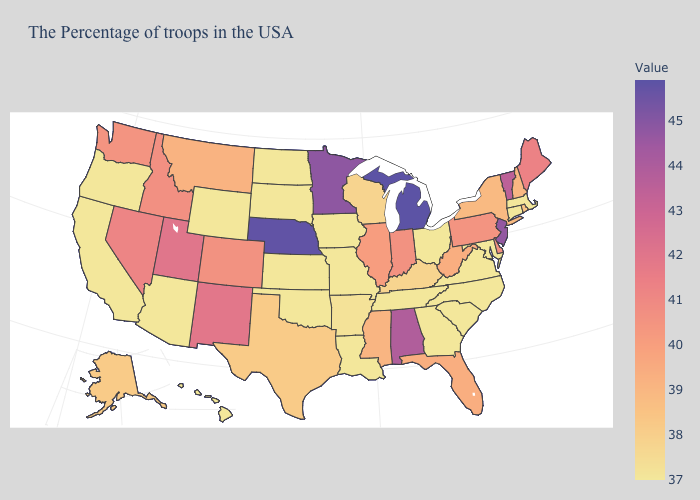Among the states that border New Hampshire , which have the lowest value?
Quick response, please. Massachusetts. Does Rhode Island have the highest value in the USA?
Be succinct. No. Does Georgia have a higher value than New Mexico?
Keep it brief. No. Among the states that border Georgia , does South Carolina have the lowest value?
Quick response, please. Yes. Does Mississippi have the lowest value in the USA?
Short answer required. No. 